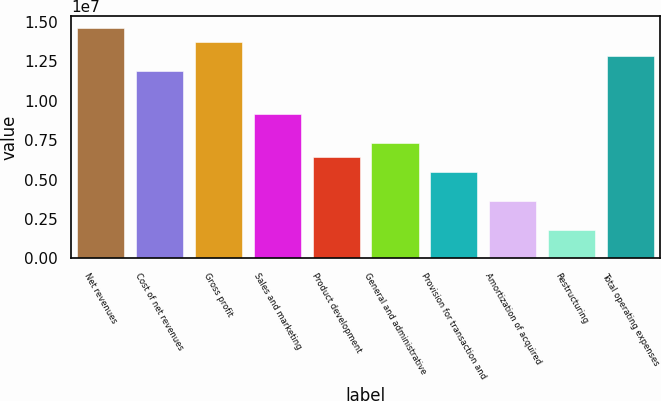Convert chart. <chart><loc_0><loc_0><loc_500><loc_500><bar_chart><fcel>Net revenues<fcel>Cost of net revenues<fcel>Gross profit<fcel>Sales and marketing<fcel>Product development<fcel>General and administrative<fcel>Provision for transaction and<fcel>Amortization of acquired<fcel>Restructuring<fcel>Total operating expenses<nl><fcel>1.465e+07<fcel>1.19032e+07<fcel>1.37344e+07<fcel>9.15627e+06<fcel>6.40939e+06<fcel>7.32502e+06<fcel>5.49376e+06<fcel>3.66251e+06<fcel>1.83126e+06<fcel>1.28188e+07<nl></chart> 